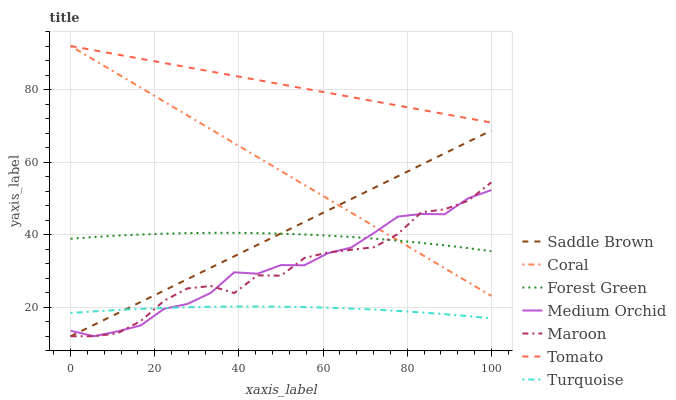Does Turquoise have the minimum area under the curve?
Answer yes or no. Yes. Does Tomato have the maximum area under the curve?
Answer yes or no. Yes. Does Coral have the minimum area under the curve?
Answer yes or no. No. Does Coral have the maximum area under the curve?
Answer yes or no. No. Is Saddle Brown the smoothest?
Answer yes or no. Yes. Is Maroon the roughest?
Answer yes or no. Yes. Is Turquoise the smoothest?
Answer yes or no. No. Is Turquoise the roughest?
Answer yes or no. No. Does Medium Orchid have the lowest value?
Answer yes or no. Yes. Does Turquoise have the lowest value?
Answer yes or no. No. Does Coral have the highest value?
Answer yes or no. Yes. Does Turquoise have the highest value?
Answer yes or no. No. Is Turquoise less than Tomato?
Answer yes or no. Yes. Is Tomato greater than Saddle Brown?
Answer yes or no. Yes. Does Forest Green intersect Coral?
Answer yes or no. Yes. Is Forest Green less than Coral?
Answer yes or no. No. Is Forest Green greater than Coral?
Answer yes or no. No. Does Turquoise intersect Tomato?
Answer yes or no. No. 